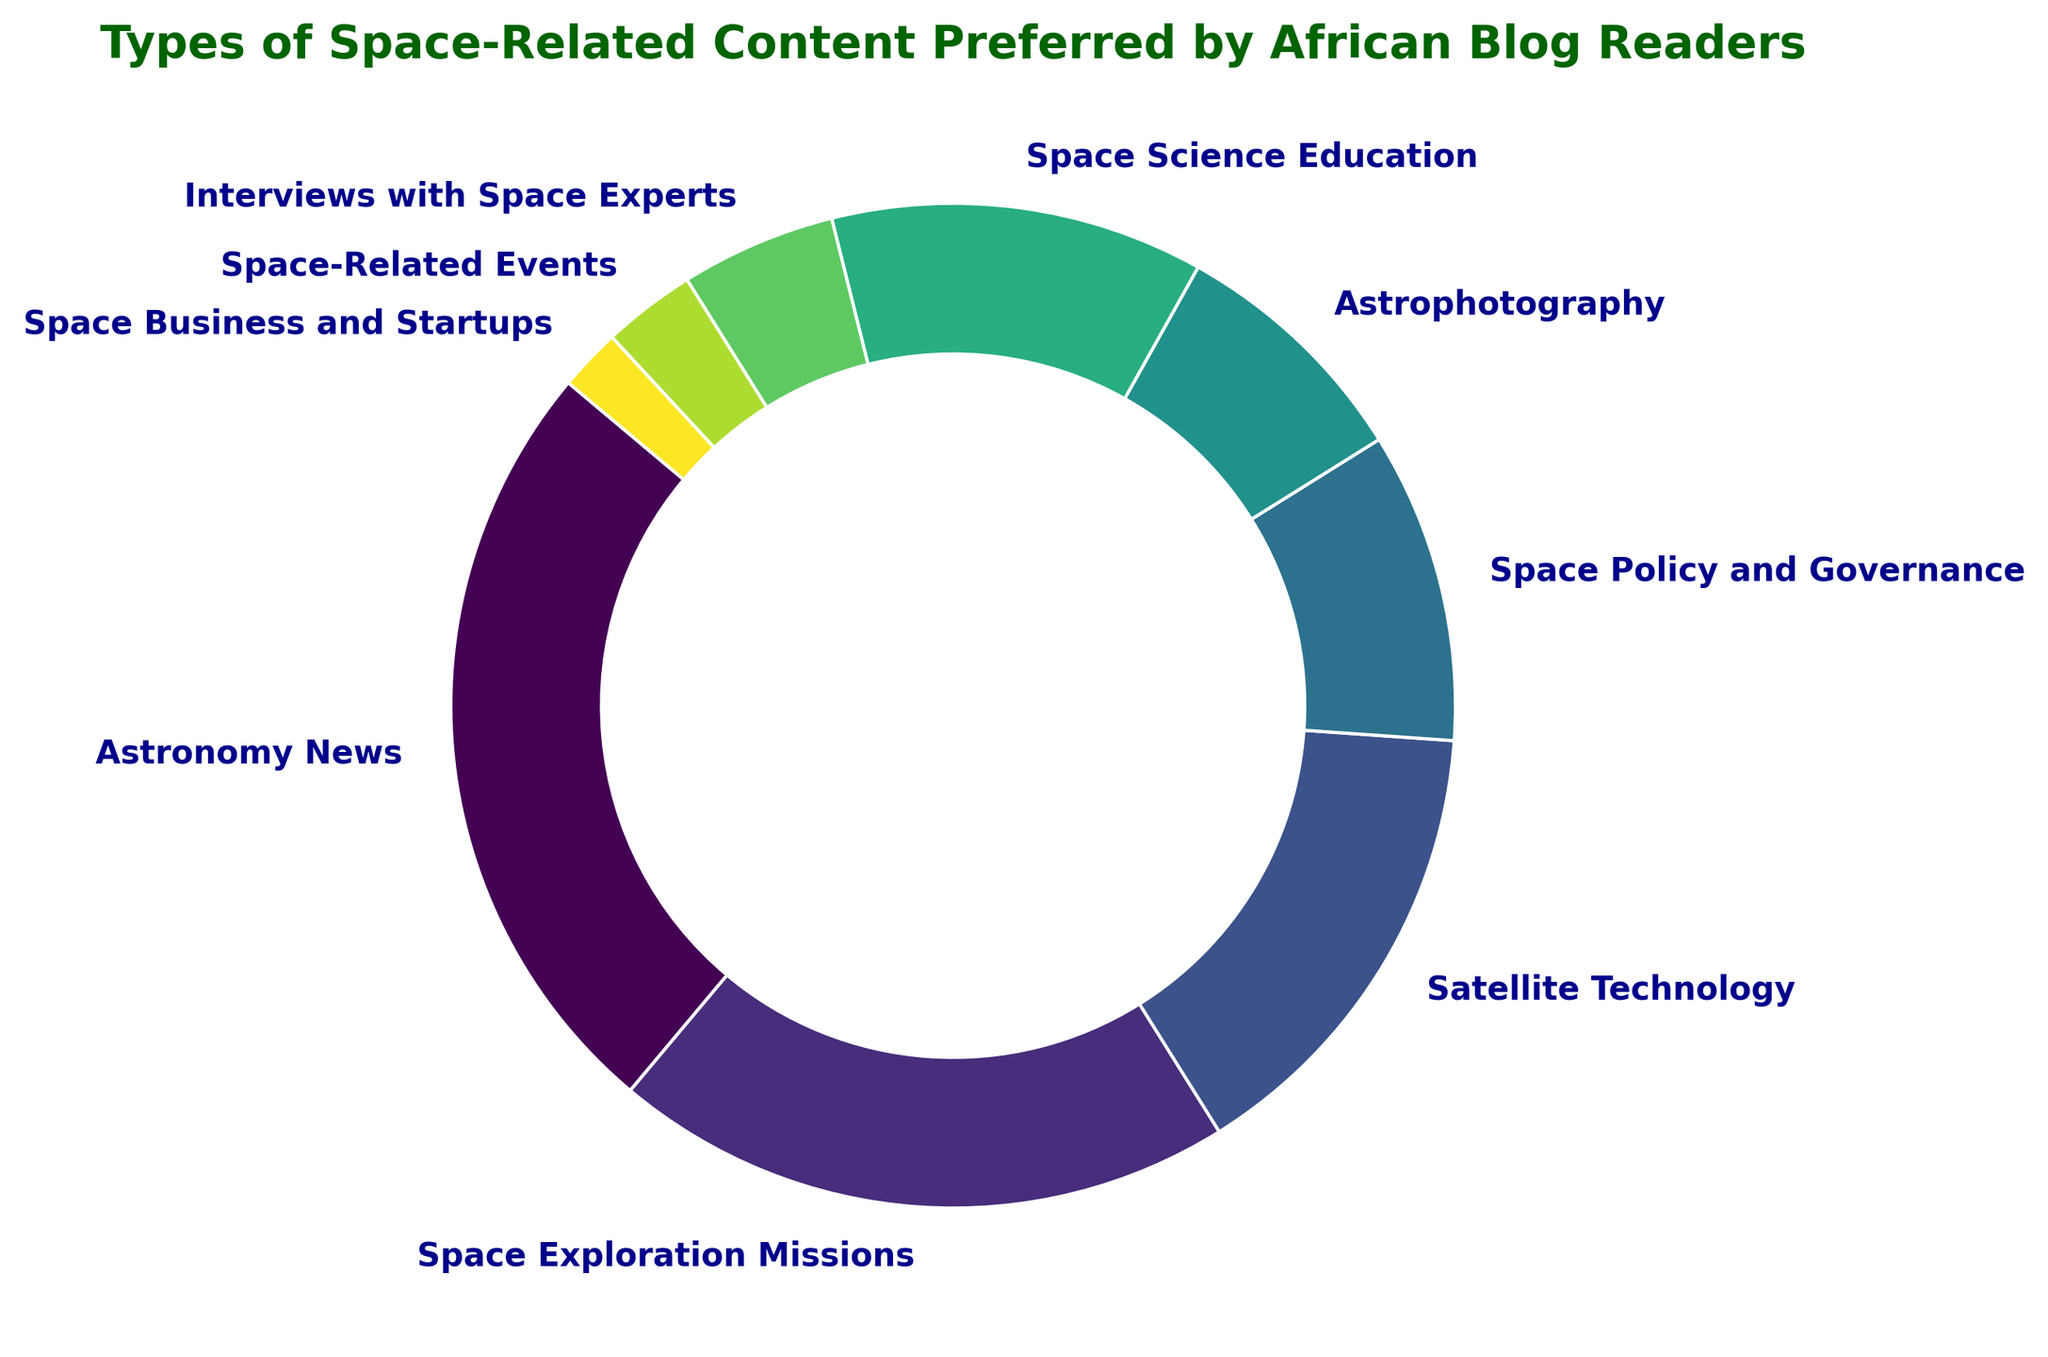What percentage of readers prefer Astronomy News? The segment labeled "Astronomy News" makes up 25% of the ring chart. Therefore, the percentage of readers who prefer Astronomy News is 25%.
Answer: 25% Which content type is preferred by the least percentage of readers, and what is that percentage? The segment labeled "Space Business and Startups" is the smallest in the ring chart, indicating the lowest preference at 2%.
Answer: Space Business and Startups, 2% How do the preferences for Space Science Education and Space Exploration Missions compare in terms of percentage? Space Science Education is preferred by 12% of readers, while Space Exploration Missions is preferred by 20%. Therefore, Space Exploration Missions have a higher preference by 8%.
Answer: Space Exploration Missions preferred by 8% more What is the combined percentage of readers preferring Satellite Technology and Astrophotography? Satellite Technology has 15%, and Astrophotography has 8%. Adding these percentages together: 15% + 8% = 23%.
Answer: 23% Is Space Policy and Governance more or less preferred than Space Science Education, and by how much? Space Policy and Governance is preferred by 10%, while Space Science Education is preferred by 12%. Space Policy and Governance is less preferred by 2%.
Answer: Less preferred by 2% Which content type has the highest preference after Astronomy News? After Astronomy News, which is preferred by 25%, the next highest preference is for Space Exploration Missions at 20%.
Answer: Space Exploration Missions What percentage of readers prefer content types categorized under Space Exploration Missions and Space Policy and Governance together? Space Exploration Missions make up 20%, and Space Policy and Governance make up 10%. Adding these together: 20% + 10% = 30%.
Answer: 30% Determine if the sum of preferences for the bottom three content types matches that of the highest preferred content type. The bottom three content types are Space Business and Startups (2%), Space-Related Events (3%), and Interviews with Space Experts (5%). Adding these: 2% + 3% + 5% = 10%. The highest preferred type, Astronomy News, has 25%. Therefore, it does not match.
Answer: No, it does not match What is the difference in the combined percentage of the two most preferred content types and the least preferred content type? The two most preferred content types are Astronomy News (25%) and Space Exploration Missions (20%), combined: 25% + 20% = 45%. The least preferred is Space Business and Startups at 2%. The difference: 45% - 2% = 43%.
Answer: 43% Which segments are represented by colors at the two extremes of the color spectrum? Based on the viridis colormap, the darkest segment (towards green) is Astronomy News and the lightest segment (towards yellow) is Space Business and Startups.
Answer: Astronomy News and Space Business and Startups 